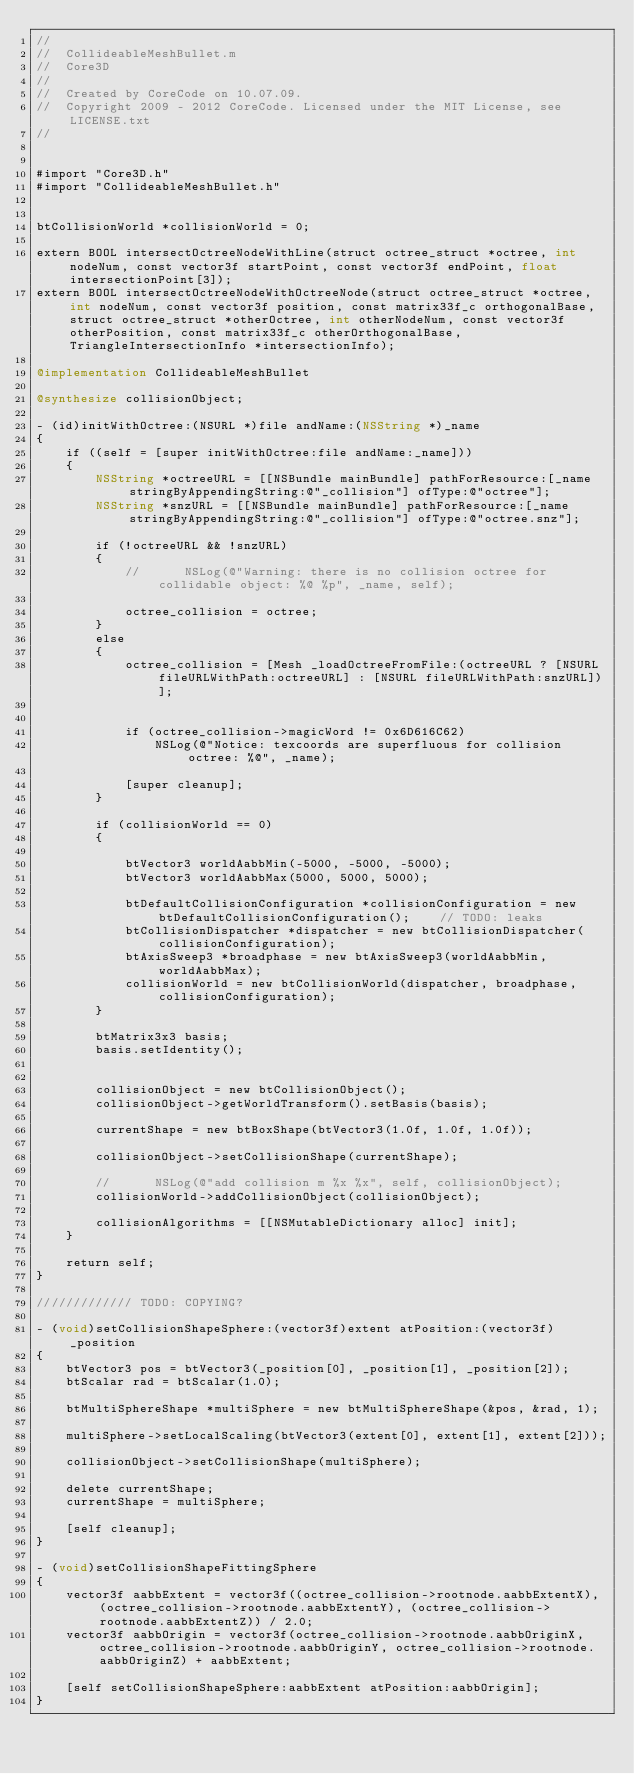Convert code to text. <code><loc_0><loc_0><loc_500><loc_500><_ObjectiveC_>//
//  CollideableMeshBullet.m
//  Core3D
//
//  Created by CoreCode on 10.07.09.
//  Copyright 2009 - 2012 CoreCode. Licensed under the MIT License, see LICENSE.txt
//


#import "Core3D.h"
#import "CollideableMeshBullet.h"


btCollisionWorld *collisionWorld = 0;

extern BOOL intersectOctreeNodeWithLine(struct octree_struct *octree, int nodeNum, const vector3f startPoint, const vector3f endPoint, float intersectionPoint[3]);
extern BOOL intersectOctreeNodeWithOctreeNode(struct octree_struct *octree, int nodeNum, const vector3f position, const matrix33f_c orthogonalBase, struct octree_struct *otherOctree, int otherNodeNum, const vector3f otherPosition, const matrix33f_c otherOrthogonalBase, TriangleIntersectionInfo *intersectionInfo);

@implementation CollideableMeshBullet

@synthesize collisionObject;

- (id)initWithOctree:(NSURL *)file andName:(NSString *)_name
{
	if ((self = [super initWithOctree:file andName:_name]))
	{
		NSString *octreeURL = [[NSBundle mainBundle] pathForResource:[_name stringByAppendingString:@"_collision"] ofType:@"octree"];
		NSString *snzURL = [[NSBundle mainBundle] pathForResource:[_name stringByAppendingString:@"_collision"] ofType:@"octree.snz"];

		if (!octreeURL && !snzURL)
		{
			//		NSLog(@"Warning: there is no collision octree for collidable object: %@ %p", _name, self);

			octree_collision = octree;
		}
		else
		{
			octree_collision = [Mesh _loadOctreeFromFile:(octreeURL ? [NSURL fileURLWithPath:octreeURL] : [NSURL fileURLWithPath:snzURL])];


			if (octree_collision->magicWord != 0x6D616C62)
				NSLog(@"Notice: texcoords are superfluous for collision octree: %@", _name);

			[super cleanup];
		}

		if (collisionWorld == 0)
		{

			btVector3 worldAabbMin(-5000, -5000, -5000);
			btVector3 worldAabbMax(5000, 5000, 5000);

			btDefaultCollisionConfiguration *collisionConfiguration = new btDefaultCollisionConfiguration();    // TODO: leaks
			btCollisionDispatcher *dispatcher = new btCollisionDispatcher(collisionConfiguration);
			btAxisSweep3 *broadphase = new btAxisSweep3(worldAabbMin, worldAabbMax);
			collisionWorld = new btCollisionWorld(dispatcher, broadphase, collisionConfiguration);
		}

		btMatrix3x3 basis;
		basis.setIdentity();


		collisionObject = new btCollisionObject();
		collisionObject->getWorldTransform().setBasis(basis);

		currentShape = new btBoxShape(btVector3(1.0f, 1.0f, 1.0f));

		collisionObject->setCollisionShape(currentShape);

		//      NSLog(@"add collision m %x %x", self, collisionObject);
		collisionWorld->addCollisionObject(collisionObject);

		collisionAlgorithms = [[NSMutableDictionary alloc] init];
	}

	return self;
}

///////////// TODO: COPYING?

- (void)setCollisionShapeSphere:(vector3f)extent atPosition:(vector3f)_position
{
	btVector3 pos = btVector3(_position[0], _position[1], _position[2]);
	btScalar rad = btScalar(1.0);

	btMultiSphereShape *multiSphere = new btMultiSphereShape(&pos, &rad, 1);

	multiSphere->setLocalScaling(btVector3(extent[0], extent[1], extent[2]));

	collisionObject->setCollisionShape(multiSphere);

	delete currentShape;
	currentShape = multiSphere;

	[self cleanup];
}

- (void)setCollisionShapeFittingSphere
{
	vector3f aabbExtent = vector3f((octree_collision->rootnode.aabbExtentX), (octree_collision->rootnode.aabbExtentY), (octree_collision->rootnode.aabbExtentZ)) / 2.0;
	vector3f aabbOrigin = vector3f(octree_collision->rootnode.aabbOriginX, octree_collision->rootnode.aabbOriginY, octree_collision->rootnode.aabbOriginZ) + aabbExtent;

	[self setCollisionShapeSphere:aabbExtent atPosition:aabbOrigin];
}
</code> 